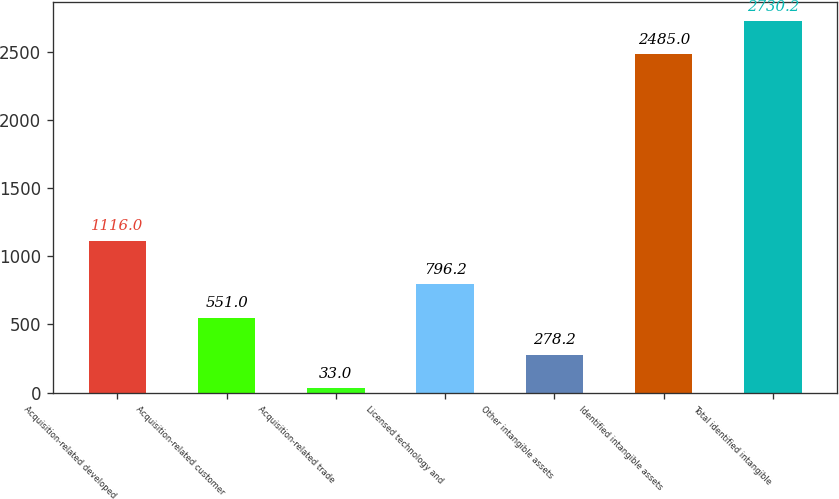<chart> <loc_0><loc_0><loc_500><loc_500><bar_chart><fcel>Acquisition-related developed<fcel>Acquisition-related customer<fcel>Acquisition-related trade<fcel>Licensed technology and<fcel>Other intangible assets<fcel>Identified intangible assets<fcel>Total identified intangible<nl><fcel>1116<fcel>551<fcel>33<fcel>796.2<fcel>278.2<fcel>2485<fcel>2730.2<nl></chart> 